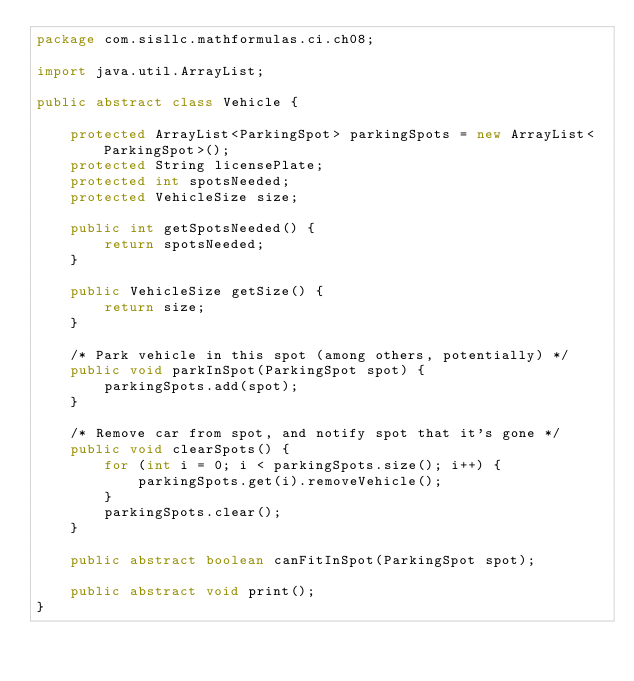<code> <loc_0><loc_0><loc_500><loc_500><_Java_>package com.sisllc.mathformulas.ci.ch08;

import java.util.ArrayList;

public abstract class Vehicle {

    protected ArrayList<ParkingSpot> parkingSpots = new ArrayList<ParkingSpot>();
    protected String licensePlate;
    protected int spotsNeeded;
    protected VehicleSize size;

    public int getSpotsNeeded() {
        return spotsNeeded;
    }

    public VehicleSize getSize() {
        return size;
    }

    /* Park vehicle in this spot (among others, potentially) */
    public void parkInSpot(ParkingSpot spot) {
        parkingSpots.add(spot);
    }

    /* Remove car from spot, and notify spot that it's gone */
    public void clearSpots() {
        for (int i = 0; i < parkingSpots.size(); i++) {
            parkingSpots.get(i).removeVehicle();
        }
        parkingSpots.clear();
    }

    public abstract boolean canFitInSpot(ParkingSpot spot);

    public abstract void print();
}
</code> 